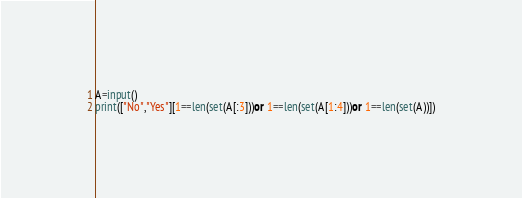Convert code to text. <code><loc_0><loc_0><loc_500><loc_500><_Python_>A=input()
print(["No","Yes"][1==len(set(A[:3]))or 1==len(set(A[1:4]))or 1==len(set(A))])</code> 